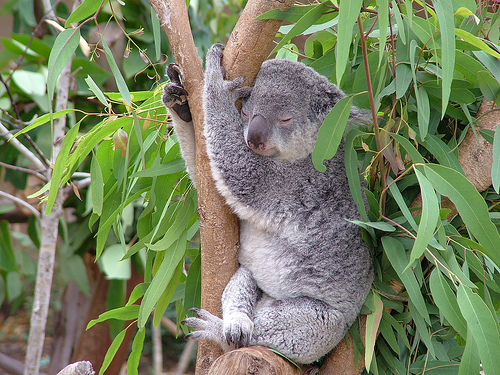<image>
Is there a branch behind the koala? Yes. From this viewpoint, the branch is positioned behind the koala, with the koala partially or fully occluding the branch. 